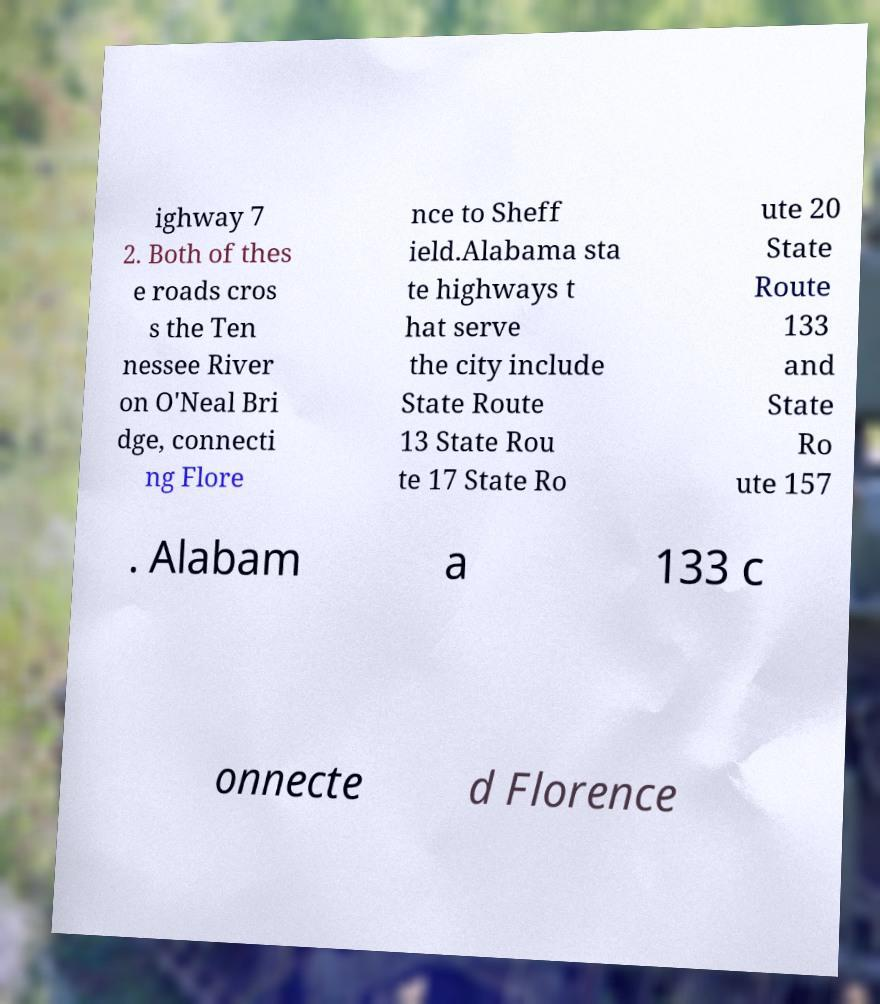Could you extract and type out the text from this image? ighway 7 2. Both of thes e roads cros s the Ten nessee River on O'Neal Bri dge, connecti ng Flore nce to Sheff ield.Alabama sta te highways t hat serve the city include State Route 13 State Rou te 17 State Ro ute 20 State Route 133 and State Ro ute 157 . Alabam a 133 c onnecte d Florence 